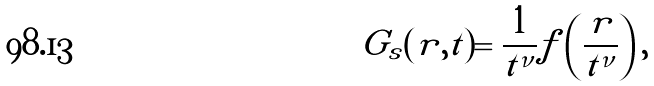Convert formula to latex. <formula><loc_0><loc_0><loc_500><loc_500>G _ { s } ( r , t ) = \frac { 1 } { t ^ { \nu } } f \left ( \frac { r } { t ^ { \nu } } \right ) ,</formula> 